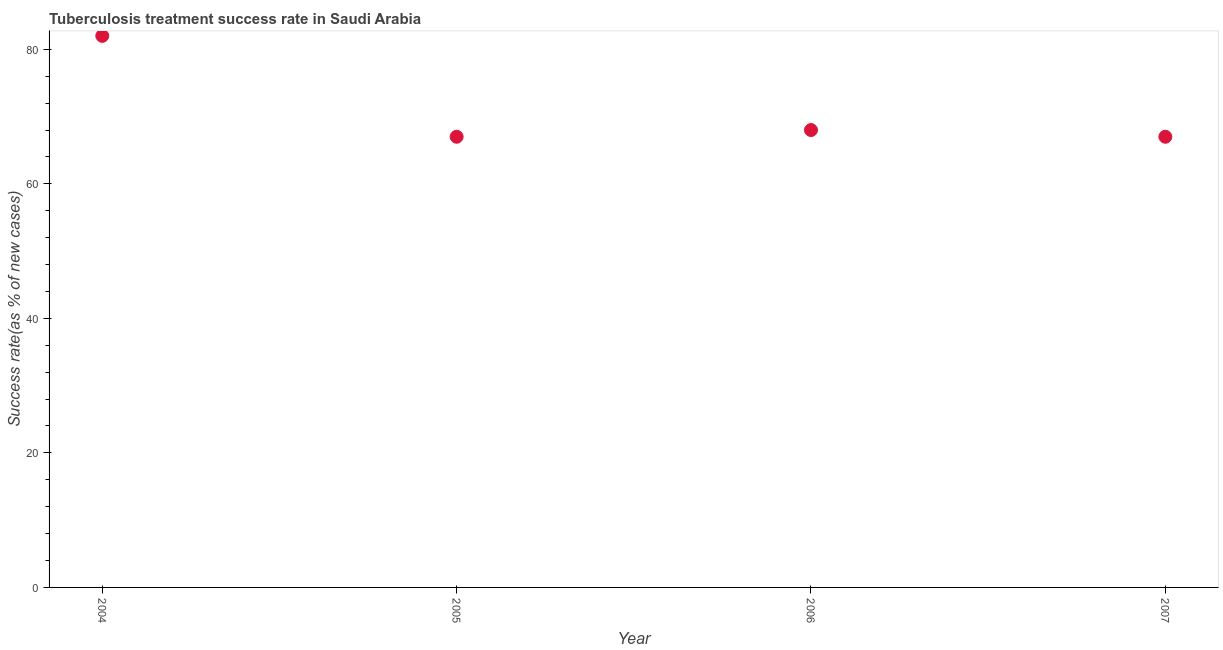What is the tuberculosis treatment success rate in 2007?
Your answer should be compact. 67. Across all years, what is the maximum tuberculosis treatment success rate?
Keep it short and to the point. 82. Across all years, what is the minimum tuberculosis treatment success rate?
Offer a very short reply. 67. In which year was the tuberculosis treatment success rate minimum?
Provide a succinct answer. 2005. What is the sum of the tuberculosis treatment success rate?
Provide a short and direct response. 284. What is the median tuberculosis treatment success rate?
Offer a very short reply. 67.5. What is the ratio of the tuberculosis treatment success rate in 2004 to that in 2005?
Offer a terse response. 1.22. Is the tuberculosis treatment success rate in 2004 less than that in 2005?
Make the answer very short. No. Is the sum of the tuberculosis treatment success rate in 2004 and 2006 greater than the maximum tuberculosis treatment success rate across all years?
Offer a very short reply. Yes. What is the difference between the highest and the lowest tuberculosis treatment success rate?
Make the answer very short. 15. In how many years, is the tuberculosis treatment success rate greater than the average tuberculosis treatment success rate taken over all years?
Offer a very short reply. 1. Does the tuberculosis treatment success rate monotonically increase over the years?
Give a very brief answer. No. How many years are there in the graph?
Offer a terse response. 4. What is the title of the graph?
Your response must be concise. Tuberculosis treatment success rate in Saudi Arabia. What is the label or title of the X-axis?
Make the answer very short. Year. What is the label or title of the Y-axis?
Give a very brief answer. Success rate(as % of new cases). What is the Success rate(as % of new cases) in 2007?
Your answer should be very brief. 67. What is the difference between the Success rate(as % of new cases) in 2004 and 2007?
Make the answer very short. 15. What is the difference between the Success rate(as % of new cases) in 2005 and 2007?
Offer a very short reply. 0. What is the ratio of the Success rate(as % of new cases) in 2004 to that in 2005?
Your answer should be compact. 1.22. What is the ratio of the Success rate(as % of new cases) in 2004 to that in 2006?
Provide a short and direct response. 1.21. What is the ratio of the Success rate(as % of new cases) in 2004 to that in 2007?
Make the answer very short. 1.22. What is the ratio of the Success rate(as % of new cases) in 2005 to that in 2007?
Your answer should be very brief. 1. 